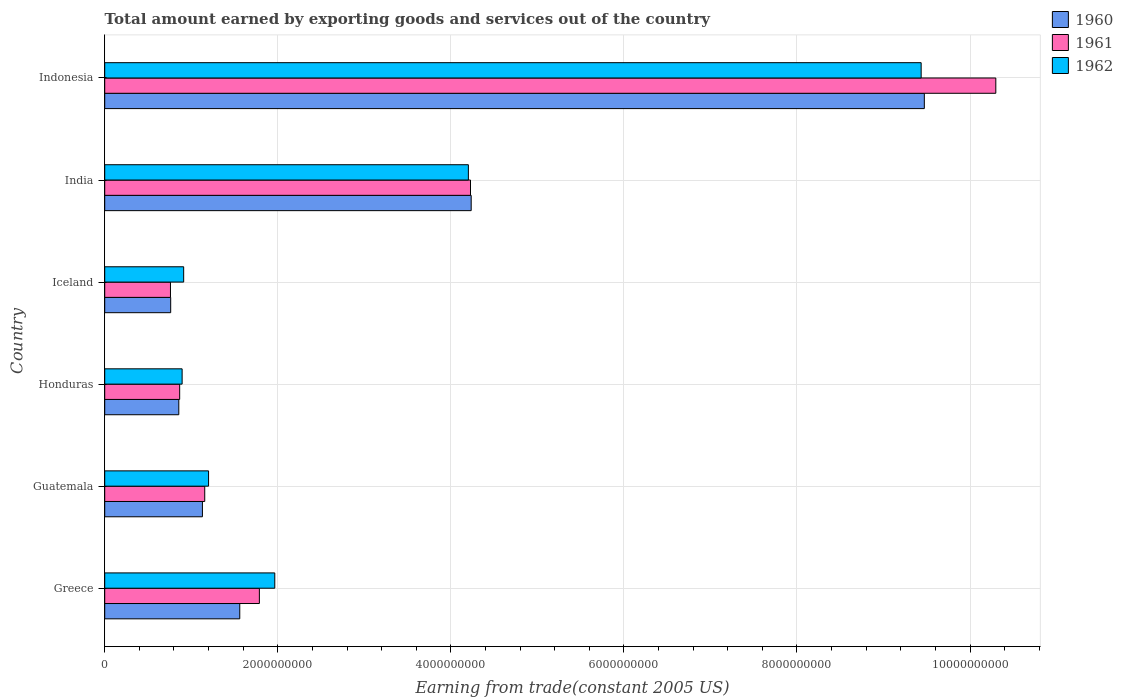How many different coloured bars are there?
Give a very brief answer. 3. How many bars are there on the 3rd tick from the bottom?
Provide a short and direct response. 3. In how many cases, is the number of bars for a given country not equal to the number of legend labels?
Provide a succinct answer. 0. What is the total amount earned by exporting goods and services in 1962 in Indonesia?
Provide a succinct answer. 9.44e+09. Across all countries, what is the maximum total amount earned by exporting goods and services in 1962?
Your answer should be very brief. 9.44e+09. Across all countries, what is the minimum total amount earned by exporting goods and services in 1960?
Provide a short and direct response. 7.62e+08. In which country was the total amount earned by exporting goods and services in 1960 maximum?
Give a very brief answer. Indonesia. In which country was the total amount earned by exporting goods and services in 1962 minimum?
Provide a succinct answer. Honduras. What is the total total amount earned by exporting goods and services in 1961 in the graph?
Offer a terse response. 1.91e+1. What is the difference between the total amount earned by exporting goods and services in 1962 in Guatemala and that in India?
Your response must be concise. -3.00e+09. What is the difference between the total amount earned by exporting goods and services in 1960 in Guatemala and the total amount earned by exporting goods and services in 1962 in Indonesia?
Your answer should be compact. -8.31e+09. What is the average total amount earned by exporting goods and services in 1961 per country?
Your response must be concise. 3.18e+09. What is the difference between the total amount earned by exporting goods and services in 1960 and total amount earned by exporting goods and services in 1961 in India?
Give a very brief answer. 7.87e+06. What is the ratio of the total amount earned by exporting goods and services in 1961 in Guatemala to that in Indonesia?
Ensure brevity in your answer.  0.11. What is the difference between the highest and the second highest total amount earned by exporting goods and services in 1962?
Your answer should be very brief. 5.23e+09. What is the difference between the highest and the lowest total amount earned by exporting goods and services in 1960?
Your answer should be very brief. 8.71e+09. Are all the bars in the graph horizontal?
Give a very brief answer. Yes. How many countries are there in the graph?
Give a very brief answer. 6. What is the difference between two consecutive major ticks on the X-axis?
Your response must be concise. 2.00e+09. Does the graph contain any zero values?
Keep it short and to the point. No. Does the graph contain grids?
Keep it short and to the point. Yes. Where does the legend appear in the graph?
Make the answer very short. Top right. How many legend labels are there?
Keep it short and to the point. 3. How are the legend labels stacked?
Make the answer very short. Vertical. What is the title of the graph?
Your answer should be compact. Total amount earned by exporting goods and services out of the country. Does "1978" appear as one of the legend labels in the graph?
Your response must be concise. No. What is the label or title of the X-axis?
Your answer should be compact. Earning from trade(constant 2005 US). What is the Earning from trade(constant 2005 US) of 1960 in Greece?
Provide a short and direct response. 1.56e+09. What is the Earning from trade(constant 2005 US) in 1961 in Greece?
Your response must be concise. 1.79e+09. What is the Earning from trade(constant 2005 US) of 1962 in Greece?
Provide a short and direct response. 1.97e+09. What is the Earning from trade(constant 2005 US) in 1960 in Guatemala?
Your answer should be compact. 1.13e+09. What is the Earning from trade(constant 2005 US) in 1961 in Guatemala?
Offer a very short reply. 1.16e+09. What is the Earning from trade(constant 2005 US) in 1962 in Guatemala?
Your response must be concise. 1.20e+09. What is the Earning from trade(constant 2005 US) in 1960 in Honduras?
Provide a succinct answer. 8.56e+08. What is the Earning from trade(constant 2005 US) of 1961 in Honduras?
Provide a succinct answer. 8.66e+08. What is the Earning from trade(constant 2005 US) in 1962 in Honduras?
Give a very brief answer. 8.95e+08. What is the Earning from trade(constant 2005 US) of 1960 in Iceland?
Provide a short and direct response. 7.62e+08. What is the Earning from trade(constant 2005 US) in 1961 in Iceland?
Keep it short and to the point. 7.60e+08. What is the Earning from trade(constant 2005 US) of 1962 in Iceland?
Your answer should be compact. 9.12e+08. What is the Earning from trade(constant 2005 US) in 1960 in India?
Give a very brief answer. 4.24e+09. What is the Earning from trade(constant 2005 US) in 1961 in India?
Keep it short and to the point. 4.23e+09. What is the Earning from trade(constant 2005 US) of 1962 in India?
Keep it short and to the point. 4.20e+09. What is the Earning from trade(constant 2005 US) of 1960 in Indonesia?
Your answer should be very brief. 9.47e+09. What is the Earning from trade(constant 2005 US) of 1961 in Indonesia?
Provide a short and direct response. 1.03e+1. What is the Earning from trade(constant 2005 US) of 1962 in Indonesia?
Provide a succinct answer. 9.44e+09. Across all countries, what is the maximum Earning from trade(constant 2005 US) of 1960?
Provide a short and direct response. 9.47e+09. Across all countries, what is the maximum Earning from trade(constant 2005 US) in 1961?
Provide a short and direct response. 1.03e+1. Across all countries, what is the maximum Earning from trade(constant 2005 US) in 1962?
Your answer should be very brief. 9.44e+09. Across all countries, what is the minimum Earning from trade(constant 2005 US) of 1960?
Give a very brief answer. 7.62e+08. Across all countries, what is the minimum Earning from trade(constant 2005 US) of 1961?
Provide a succinct answer. 7.60e+08. Across all countries, what is the minimum Earning from trade(constant 2005 US) in 1962?
Offer a terse response. 8.95e+08. What is the total Earning from trade(constant 2005 US) in 1960 in the graph?
Give a very brief answer. 1.80e+1. What is the total Earning from trade(constant 2005 US) in 1961 in the graph?
Keep it short and to the point. 1.91e+1. What is the total Earning from trade(constant 2005 US) in 1962 in the graph?
Provide a short and direct response. 1.86e+1. What is the difference between the Earning from trade(constant 2005 US) in 1960 in Greece and that in Guatemala?
Keep it short and to the point. 4.31e+08. What is the difference between the Earning from trade(constant 2005 US) in 1961 in Greece and that in Guatemala?
Offer a very short reply. 6.32e+08. What is the difference between the Earning from trade(constant 2005 US) in 1962 in Greece and that in Guatemala?
Give a very brief answer. 7.65e+08. What is the difference between the Earning from trade(constant 2005 US) in 1960 in Greece and that in Honduras?
Keep it short and to the point. 7.05e+08. What is the difference between the Earning from trade(constant 2005 US) of 1961 in Greece and that in Honduras?
Offer a very short reply. 9.21e+08. What is the difference between the Earning from trade(constant 2005 US) in 1962 in Greece and that in Honduras?
Provide a short and direct response. 1.07e+09. What is the difference between the Earning from trade(constant 2005 US) of 1960 in Greece and that in Iceland?
Keep it short and to the point. 7.98e+08. What is the difference between the Earning from trade(constant 2005 US) in 1961 in Greece and that in Iceland?
Give a very brief answer. 1.03e+09. What is the difference between the Earning from trade(constant 2005 US) of 1962 in Greece and that in Iceland?
Make the answer very short. 1.05e+09. What is the difference between the Earning from trade(constant 2005 US) in 1960 in Greece and that in India?
Offer a terse response. -2.67e+09. What is the difference between the Earning from trade(constant 2005 US) of 1961 in Greece and that in India?
Your answer should be compact. -2.44e+09. What is the difference between the Earning from trade(constant 2005 US) in 1962 in Greece and that in India?
Provide a succinct answer. -2.24e+09. What is the difference between the Earning from trade(constant 2005 US) of 1960 in Greece and that in Indonesia?
Provide a succinct answer. -7.91e+09. What is the difference between the Earning from trade(constant 2005 US) of 1961 in Greece and that in Indonesia?
Ensure brevity in your answer.  -8.51e+09. What is the difference between the Earning from trade(constant 2005 US) of 1962 in Greece and that in Indonesia?
Your answer should be very brief. -7.47e+09. What is the difference between the Earning from trade(constant 2005 US) of 1960 in Guatemala and that in Honduras?
Your response must be concise. 2.73e+08. What is the difference between the Earning from trade(constant 2005 US) in 1961 in Guatemala and that in Honduras?
Provide a short and direct response. 2.89e+08. What is the difference between the Earning from trade(constant 2005 US) in 1962 in Guatemala and that in Honduras?
Give a very brief answer. 3.06e+08. What is the difference between the Earning from trade(constant 2005 US) of 1960 in Guatemala and that in Iceland?
Ensure brevity in your answer.  3.67e+08. What is the difference between the Earning from trade(constant 2005 US) in 1961 in Guatemala and that in Iceland?
Provide a succinct answer. 3.96e+08. What is the difference between the Earning from trade(constant 2005 US) of 1962 in Guatemala and that in Iceland?
Give a very brief answer. 2.88e+08. What is the difference between the Earning from trade(constant 2005 US) in 1960 in Guatemala and that in India?
Offer a very short reply. -3.11e+09. What is the difference between the Earning from trade(constant 2005 US) in 1961 in Guatemala and that in India?
Provide a short and direct response. -3.07e+09. What is the difference between the Earning from trade(constant 2005 US) of 1962 in Guatemala and that in India?
Ensure brevity in your answer.  -3.00e+09. What is the difference between the Earning from trade(constant 2005 US) in 1960 in Guatemala and that in Indonesia?
Your response must be concise. -8.34e+09. What is the difference between the Earning from trade(constant 2005 US) in 1961 in Guatemala and that in Indonesia?
Offer a very short reply. -9.14e+09. What is the difference between the Earning from trade(constant 2005 US) of 1962 in Guatemala and that in Indonesia?
Make the answer very short. -8.24e+09. What is the difference between the Earning from trade(constant 2005 US) in 1960 in Honduras and that in Iceland?
Make the answer very short. 9.37e+07. What is the difference between the Earning from trade(constant 2005 US) of 1961 in Honduras and that in Iceland?
Keep it short and to the point. 1.06e+08. What is the difference between the Earning from trade(constant 2005 US) in 1962 in Honduras and that in Iceland?
Your response must be concise. -1.79e+07. What is the difference between the Earning from trade(constant 2005 US) of 1960 in Honduras and that in India?
Provide a succinct answer. -3.38e+09. What is the difference between the Earning from trade(constant 2005 US) of 1961 in Honduras and that in India?
Provide a short and direct response. -3.36e+09. What is the difference between the Earning from trade(constant 2005 US) in 1962 in Honduras and that in India?
Ensure brevity in your answer.  -3.31e+09. What is the difference between the Earning from trade(constant 2005 US) in 1960 in Honduras and that in Indonesia?
Ensure brevity in your answer.  -8.62e+09. What is the difference between the Earning from trade(constant 2005 US) of 1961 in Honduras and that in Indonesia?
Provide a succinct answer. -9.43e+09. What is the difference between the Earning from trade(constant 2005 US) of 1962 in Honduras and that in Indonesia?
Keep it short and to the point. -8.54e+09. What is the difference between the Earning from trade(constant 2005 US) in 1960 in Iceland and that in India?
Make the answer very short. -3.47e+09. What is the difference between the Earning from trade(constant 2005 US) in 1961 in Iceland and that in India?
Give a very brief answer. -3.47e+09. What is the difference between the Earning from trade(constant 2005 US) of 1962 in Iceland and that in India?
Your answer should be compact. -3.29e+09. What is the difference between the Earning from trade(constant 2005 US) of 1960 in Iceland and that in Indonesia?
Ensure brevity in your answer.  -8.71e+09. What is the difference between the Earning from trade(constant 2005 US) of 1961 in Iceland and that in Indonesia?
Offer a very short reply. -9.54e+09. What is the difference between the Earning from trade(constant 2005 US) of 1962 in Iceland and that in Indonesia?
Give a very brief answer. -8.52e+09. What is the difference between the Earning from trade(constant 2005 US) of 1960 in India and that in Indonesia?
Ensure brevity in your answer.  -5.24e+09. What is the difference between the Earning from trade(constant 2005 US) in 1961 in India and that in Indonesia?
Make the answer very short. -6.07e+09. What is the difference between the Earning from trade(constant 2005 US) in 1962 in India and that in Indonesia?
Offer a terse response. -5.23e+09. What is the difference between the Earning from trade(constant 2005 US) of 1960 in Greece and the Earning from trade(constant 2005 US) of 1961 in Guatemala?
Ensure brevity in your answer.  4.05e+08. What is the difference between the Earning from trade(constant 2005 US) of 1960 in Greece and the Earning from trade(constant 2005 US) of 1962 in Guatemala?
Keep it short and to the point. 3.61e+08. What is the difference between the Earning from trade(constant 2005 US) in 1961 in Greece and the Earning from trade(constant 2005 US) in 1962 in Guatemala?
Offer a terse response. 5.87e+08. What is the difference between the Earning from trade(constant 2005 US) in 1960 in Greece and the Earning from trade(constant 2005 US) in 1961 in Honduras?
Offer a very short reply. 6.94e+08. What is the difference between the Earning from trade(constant 2005 US) in 1960 in Greece and the Earning from trade(constant 2005 US) in 1962 in Honduras?
Provide a succinct answer. 6.66e+08. What is the difference between the Earning from trade(constant 2005 US) of 1961 in Greece and the Earning from trade(constant 2005 US) of 1962 in Honduras?
Give a very brief answer. 8.93e+08. What is the difference between the Earning from trade(constant 2005 US) of 1960 in Greece and the Earning from trade(constant 2005 US) of 1961 in Iceland?
Your answer should be very brief. 8.01e+08. What is the difference between the Earning from trade(constant 2005 US) in 1960 in Greece and the Earning from trade(constant 2005 US) in 1962 in Iceland?
Your answer should be very brief. 6.48e+08. What is the difference between the Earning from trade(constant 2005 US) in 1961 in Greece and the Earning from trade(constant 2005 US) in 1962 in Iceland?
Provide a succinct answer. 8.75e+08. What is the difference between the Earning from trade(constant 2005 US) in 1960 in Greece and the Earning from trade(constant 2005 US) in 1961 in India?
Your answer should be very brief. -2.67e+09. What is the difference between the Earning from trade(constant 2005 US) in 1960 in Greece and the Earning from trade(constant 2005 US) in 1962 in India?
Offer a terse response. -2.64e+09. What is the difference between the Earning from trade(constant 2005 US) in 1961 in Greece and the Earning from trade(constant 2005 US) in 1962 in India?
Make the answer very short. -2.42e+09. What is the difference between the Earning from trade(constant 2005 US) of 1960 in Greece and the Earning from trade(constant 2005 US) of 1961 in Indonesia?
Keep it short and to the point. -8.74e+09. What is the difference between the Earning from trade(constant 2005 US) of 1960 in Greece and the Earning from trade(constant 2005 US) of 1962 in Indonesia?
Offer a terse response. -7.87e+09. What is the difference between the Earning from trade(constant 2005 US) of 1961 in Greece and the Earning from trade(constant 2005 US) of 1962 in Indonesia?
Provide a succinct answer. -7.65e+09. What is the difference between the Earning from trade(constant 2005 US) of 1960 in Guatemala and the Earning from trade(constant 2005 US) of 1961 in Honduras?
Provide a succinct answer. 2.63e+08. What is the difference between the Earning from trade(constant 2005 US) of 1960 in Guatemala and the Earning from trade(constant 2005 US) of 1962 in Honduras?
Offer a very short reply. 2.35e+08. What is the difference between the Earning from trade(constant 2005 US) of 1961 in Guatemala and the Earning from trade(constant 2005 US) of 1962 in Honduras?
Provide a succinct answer. 2.61e+08. What is the difference between the Earning from trade(constant 2005 US) in 1960 in Guatemala and the Earning from trade(constant 2005 US) in 1961 in Iceland?
Offer a terse response. 3.69e+08. What is the difference between the Earning from trade(constant 2005 US) of 1960 in Guatemala and the Earning from trade(constant 2005 US) of 1962 in Iceland?
Keep it short and to the point. 2.17e+08. What is the difference between the Earning from trade(constant 2005 US) in 1961 in Guatemala and the Earning from trade(constant 2005 US) in 1962 in Iceland?
Keep it short and to the point. 2.43e+08. What is the difference between the Earning from trade(constant 2005 US) in 1960 in Guatemala and the Earning from trade(constant 2005 US) in 1961 in India?
Your answer should be compact. -3.10e+09. What is the difference between the Earning from trade(constant 2005 US) of 1960 in Guatemala and the Earning from trade(constant 2005 US) of 1962 in India?
Give a very brief answer. -3.07e+09. What is the difference between the Earning from trade(constant 2005 US) of 1961 in Guatemala and the Earning from trade(constant 2005 US) of 1962 in India?
Offer a very short reply. -3.05e+09. What is the difference between the Earning from trade(constant 2005 US) of 1960 in Guatemala and the Earning from trade(constant 2005 US) of 1961 in Indonesia?
Keep it short and to the point. -9.17e+09. What is the difference between the Earning from trade(constant 2005 US) of 1960 in Guatemala and the Earning from trade(constant 2005 US) of 1962 in Indonesia?
Give a very brief answer. -8.31e+09. What is the difference between the Earning from trade(constant 2005 US) in 1961 in Guatemala and the Earning from trade(constant 2005 US) in 1962 in Indonesia?
Your answer should be compact. -8.28e+09. What is the difference between the Earning from trade(constant 2005 US) in 1960 in Honduras and the Earning from trade(constant 2005 US) in 1961 in Iceland?
Provide a short and direct response. 9.63e+07. What is the difference between the Earning from trade(constant 2005 US) of 1960 in Honduras and the Earning from trade(constant 2005 US) of 1962 in Iceland?
Provide a short and direct response. -5.63e+07. What is the difference between the Earning from trade(constant 2005 US) in 1961 in Honduras and the Earning from trade(constant 2005 US) in 1962 in Iceland?
Make the answer very short. -4.61e+07. What is the difference between the Earning from trade(constant 2005 US) in 1960 in Honduras and the Earning from trade(constant 2005 US) in 1961 in India?
Give a very brief answer. -3.37e+09. What is the difference between the Earning from trade(constant 2005 US) in 1960 in Honduras and the Earning from trade(constant 2005 US) in 1962 in India?
Your answer should be very brief. -3.35e+09. What is the difference between the Earning from trade(constant 2005 US) in 1961 in Honduras and the Earning from trade(constant 2005 US) in 1962 in India?
Make the answer very short. -3.34e+09. What is the difference between the Earning from trade(constant 2005 US) in 1960 in Honduras and the Earning from trade(constant 2005 US) in 1961 in Indonesia?
Offer a terse response. -9.44e+09. What is the difference between the Earning from trade(constant 2005 US) of 1960 in Honduras and the Earning from trade(constant 2005 US) of 1962 in Indonesia?
Make the answer very short. -8.58e+09. What is the difference between the Earning from trade(constant 2005 US) in 1961 in Honduras and the Earning from trade(constant 2005 US) in 1962 in Indonesia?
Provide a short and direct response. -8.57e+09. What is the difference between the Earning from trade(constant 2005 US) of 1960 in Iceland and the Earning from trade(constant 2005 US) of 1961 in India?
Offer a very short reply. -3.46e+09. What is the difference between the Earning from trade(constant 2005 US) in 1960 in Iceland and the Earning from trade(constant 2005 US) in 1962 in India?
Keep it short and to the point. -3.44e+09. What is the difference between the Earning from trade(constant 2005 US) in 1961 in Iceland and the Earning from trade(constant 2005 US) in 1962 in India?
Keep it short and to the point. -3.44e+09. What is the difference between the Earning from trade(constant 2005 US) in 1960 in Iceland and the Earning from trade(constant 2005 US) in 1961 in Indonesia?
Provide a succinct answer. -9.54e+09. What is the difference between the Earning from trade(constant 2005 US) in 1960 in Iceland and the Earning from trade(constant 2005 US) in 1962 in Indonesia?
Give a very brief answer. -8.67e+09. What is the difference between the Earning from trade(constant 2005 US) of 1961 in Iceland and the Earning from trade(constant 2005 US) of 1962 in Indonesia?
Keep it short and to the point. -8.68e+09. What is the difference between the Earning from trade(constant 2005 US) of 1960 in India and the Earning from trade(constant 2005 US) of 1961 in Indonesia?
Ensure brevity in your answer.  -6.06e+09. What is the difference between the Earning from trade(constant 2005 US) of 1960 in India and the Earning from trade(constant 2005 US) of 1962 in Indonesia?
Provide a succinct answer. -5.20e+09. What is the difference between the Earning from trade(constant 2005 US) in 1961 in India and the Earning from trade(constant 2005 US) in 1962 in Indonesia?
Make the answer very short. -5.21e+09. What is the average Earning from trade(constant 2005 US) of 1960 per country?
Offer a terse response. 3.00e+09. What is the average Earning from trade(constant 2005 US) in 1961 per country?
Keep it short and to the point. 3.18e+09. What is the average Earning from trade(constant 2005 US) in 1962 per country?
Your answer should be compact. 3.10e+09. What is the difference between the Earning from trade(constant 2005 US) of 1960 and Earning from trade(constant 2005 US) of 1961 in Greece?
Your answer should be very brief. -2.27e+08. What is the difference between the Earning from trade(constant 2005 US) of 1960 and Earning from trade(constant 2005 US) of 1962 in Greece?
Give a very brief answer. -4.05e+08. What is the difference between the Earning from trade(constant 2005 US) in 1961 and Earning from trade(constant 2005 US) in 1962 in Greece?
Keep it short and to the point. -1.78e+08. What is the difference between the Earning from trade(constant 2005 US) in 1960 and Earning from trade(constant 2005 US) in 1961 in Guatemala?
Provide a succinct answer. -2.66e+07. What is the difference between the Earning from trade(constant 2005 US) in 1960 and Earning from trade(constant 2005 US) in 1962 in Guatemala?
Your answer should be very brief. -7.09e+07. What is the difference between the Earning from trade(constant 2005 US) in 1961 and Earning from trade(constant 2005 US) in 1962 in Guatemala?
Make the answer very short. -4.43e+07. What is the difference between the Earning from trade(constant 2005 US) in 1960 and Earning from trade(constant 2005 US) in 1961 in Honduras?
Give a very brief answer. -1.02e+07. What is the difference between the Earning from trade(constant 2005 US) in 1960 and Earning from trade(constant 2005 US) in 1962 in Honduras?
Your answer should be compact. -3.84e+07. What is the difference between the Earning from trade(constant 2005 US) in 1961 and Earning from trade(constant 2005 US) in 1962 in Honduras?
Make the answer very short. -2.82e+07. What is the difference between the Earning from trade(constant 2005 US) of 1960 and Earning from trade(constant 2005 US) of 1961 in Iceland?
Make the answer very short. 2.61e+06. What is the difference between the Earning from trade(constant 2005 US) in 1960 and Earning from trade(constant 2005 US) in 1962 in Iceland?
Your answer should be very brief. -1.50e+08. What is the difference between the Earning from trade(constant 2005 US) in 1961 and Earning from trade(constant 2005 US) in 1962 in Iceland?
Provide a succinct answer. -1.53e+08. What is the difference between the Earning from trade(constant 2005 US) in 1960 and Earning from trade(constant 2005 US) in 1961 in India?
Offer a terse response. 7.87e+06. What is the difference between the Earning from trade(constant 2005 US) in 1960 and Earning from trade(constant 2005 US) in 1962 in India?
Provide a short and direct response. 3.24e+07. What is the difference between the Earning from trade(constant 2005 US) of 1961 and Earning from trade(constant 2005 US) of 1962 in India?
Your response must be concise. 2.45e+07. What is the difference between the Earning from trade(constant 2005 US) in 1960 and Earning from trade(constant 2005 US) in 1961 in Indonesia?
Ensure brevity in your answer.  -8.26e+08. What is the difference between the Earning from trade(constant 2005 US) of 1960 and Earning from trade(constant 2005 US) of 1962 in Indonesia?
Offer a terse response. 3.67e+07. What is the difference between the Earning from trade(constant 2005 US) in 1961 and Earning from trade(constant 2005 US) in 1962 in Indonesia?
Offer a very short reply. 8.63e+08. What is the ratio of the Earning from trade(constant 2005 US) of 1960 in Greece to that in Guatemala?
Your answer should be very brief. 1.38. What is the ratio of the Earning from trade(constant 2005 US) in 1961 in Greece to that in Guatemala?
Offer a terse response. 1.55. What is the ratio of the Earning from trade(constant 2005 US) of 1962 in Greece to that in Guatemala?
Your answer should be very brief. 1.64. What is the ratio of the Earning from trade(constant 2005 US) in 1960 in Greece to that in Honduras?
Offer a very short reply. 1.82. What is the ratio of the Earning from trade(constant 2005 US) of 1961 in Greece to that in Honduras?
Ensure brevity in your answer.  2.06. What is the ratio of the Earning from trade(constant 2005 US) of 1962 in Greece to that in Honduras?
Provide a succinct answer. 2.2. What is the ratio of the Earning from trade(constant 2005 US) of 1960 in Greece to that in Iceland?
Your answer should be compact. 2.05. What is the ratio of the Earning from trade(constant 2005 US) of 1961 in Greece to that in Iceland?
Ensure brevity in your answer.  2.35. What is the ratio of the Earning from trade(constant 2005 US) of 1962 in Greece to that in Iceland?
Your answer should be very brief. 2.15. What is the ratio of the Earning from trade(constant 2005 US) in 1960 in Greece to that in India?
Your response must be concise. 0.37. What is the ratio of the Earning from trade(constant 2005 US) of 1961 in Greece to that in India?
Offer a very short reply. 0.42. What is the ratio of the Earning from trade(constant 2005 US) of 1962 in Greece to that in India?
Provide a short and direct response. 0.47. What is the ratio of the Earning from trade(constant 2005 US) in 1960 in Greece to that in Indonesia?
Your response must be concise. 0.16. What is the ratio of the Earning from trade(constant 2005 US) in 1961 in Greece to that in Indonesia?
Make the answer very short. 0.17. What is the ratio of the Earning from trade(constant 2005 US) in 1962 in Greece to that in Indonesia?
Give a very brief answer. 0.21. What is the ratio of the Earning from trade(constant 2005 US) of 1960 in Guatemala to that in Honduras?
Offer a terse response. 1.32. What is the ratio of the Earning from trade(constant 2005 US) of 1961 in Guatemala to that in Honduras?
Offer a terse response. 1.33. What is the ratio of the Earning from trade(constant 2005 US) of 1962 in Guatemala to that in Honduras?
Ensure brevity in your answer.  1.34. What is the ratio of the Earning from trade(constant 2005 US) in 1960 in Guatemala to that in Iceland?
Make the answer very short. 1.48. What is the ratio of the Earning from trade(constant 2005 US) of 1961 in Guatemala to that in Iceland?
Your response must be concise. 1.52. What is the ratio of the Earning from trade(constant 2005 US) in 1962 in Guatemala to that in Iceland?
Your answer should be very brief. 1.32. What is the ratio of the Earning from trade(constant 2005 US) in 1960 in Guatemala to that in India?
Provide a succinct answer. 0.27. What is the ratio of the Earning from trade(constant 2005 US) in 1961 in Guatemala to that in India?
Provide a short and direct response. 0.27. What is the ratio of the Earning from trade(constant 2005 US) in 1962 in Guatemala to that in India?
Provide a succinct answer. 0.29. What is the ratio of the Earning from trade(constant 2005 US) in 1960 in Guatemala to that in Indonesia?
Give a very brief answer. 0.12. What is the ratio of the Earning from trade(constant 2005 US) of 1961 in Guatemala to that in Indonesia?
Offer a very short reply. 0.11. What is the ratio of the Earning from trade(constant 2005 US) of 1962 in Guatemala to that in Indonesia?
Offer a very short reply. 0.13. What is the ratio of the Earning from trade(constant 2005 US) of 1960 in Honduras to that in Iceland?
Your answer should be very brief. 1.12. What is the ratio of the Earning from trade(constant 2005 US) of 1961 in Honduras to that in Iceland?
Offer a very short reply. 1.14. What is the ratio of the Earning from trade(constant 2005 US) of 1962 in Honduras to that in Iceland?
Offer a terse response. 0.98. What is the ratio of the Earning from trade(constant 2005 US) of 1960 in Honduras to that in India?
Offer a very short reply. 0.2. What is the ratio of the Earning from trade(constant 2005 US) in 1961 in Honduras to that in India?
Make the answer very short. 0.2. What is the ratio of the Earning from trade(constant 2005 US) of 1962 in Honduras to that in India?
Your answer should be compact. 0.21. What is the ratio of the Earning from trade(constant 2005 US) in 1960 in Honduras to that in Indonesia?
Keep it short and to the point. 0.09. What is the ratio of the Earning from trade(constant 2005 US) of 1961 in Honduras to that in Indonesia?
Offer a very short reply. 0.08. What is the ratio of the Earning from trade(constant 2005 US) of 1962 in Honduras to that in Indonesia?
Provide a succinct answer. 0.09. What is the ratio of the Earning from trade(constant 2005 US) of 1960 in Iceland to that in India?
Provide a short and direct response. 0.18. What is the ratio of the Earning from trade(constant 2005 US) of 1961 in Iceland to that in India?
Your answer should be very brief. 0.18. What is the ratio of the Earning from trade(constant 2005 US) of 1962 in Iceland to that in India?
Offer a very short reply. 0.22. What is the ratio of the Earning from trade(constant 2005 US) in 1960 in Iceland to that in Indonesia?
Keep it short and to the point. 0.08. What is the ratio of the Earning from trade(constant 2005 US) of 1961 in Iceland to that in Indonesia?
Your answer should be compact. 0.07. What is the ratio of the Earning from trade(constant 2005 US) in 1962 in Iceland to that in Indonesia?
Offer a very short reply. 0.1. What is the ratio of the Earning from trade(constant 2005 US) in 1960 in India to that in Indonesia?
Your answer should be compact. 0.45. What is the ratio of the Earning from trade(constant 2005 US) in 1961 in India to that in Indonesia?
Your response must be concise. 0.41. What is the ratio of the Earning from trade(constant 2005 US) of 1962 in India to that in Indonesia?
Your answer should be very brief. 0.45. What is the difference between the highest and the second highest Earning from trade(constant 2005 US) of 1960?
Offer a terse response. 5.24e+09. What is the difference between the highest and the second highest Earning from trade(constant 2005 US) in 1961?
Provide a short and direct response. 6.07e+09. What is the difference between the highest and the second highest Earning from trade(constant 2005 US) in 1962?
Make the answer very short. 5.23e+09. What is the difference between the highest and the lowest Earning from trade(constant 2005 US) of 1960?
Provide a short and direct response. 8.71e+09. What is the difference between the highest and the lowest Earning from trade(constant 2005 US) in 1961?
Make the answer very short. 9.54e+09. What is the difference between the highest and the lowest Earning from trade(constant 2005 US) in 1962?
Make the answer very short. 8.54e+09. 